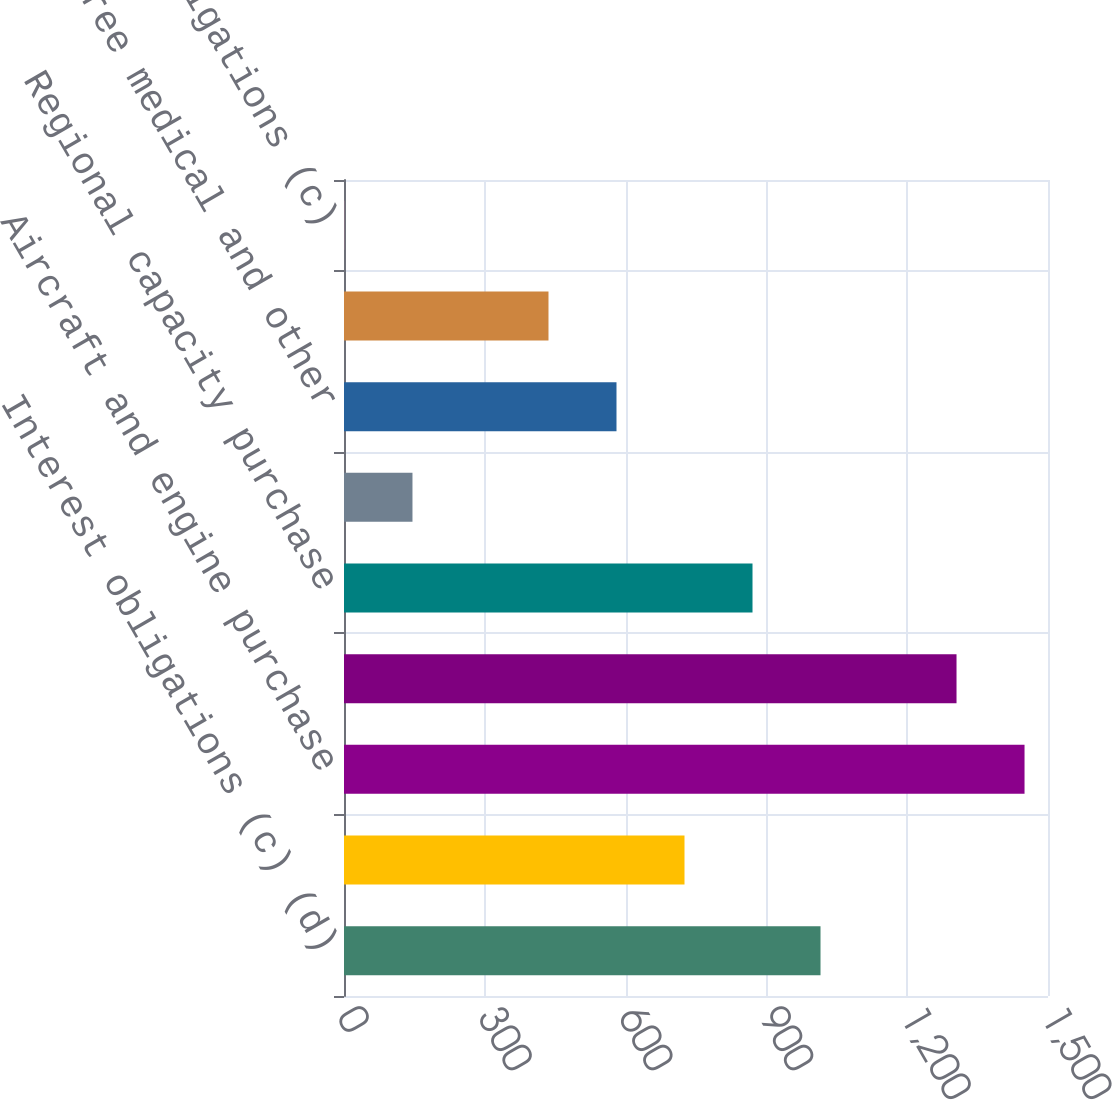Convert chart. <chart><loc_0><loc_0><loc_500><loc_500><bar_chart><fcel>Interest obligations (c) (d)<fcel>Finance lease obligations (See<fcel>Aircraft and engine purchase<fcel>Operating lease commitments<fcel>Regional capacity purchase<fcel>Minimum pension obligations<fcel>Retiree medical and other<fcel>Other purchase obligations (i)<fcel>Interest obligations (c)<nl><fcel>1015.3<fcel>725.5<fcel>1450<fcel>1305.1<fcel>870.4<fcel>145.9<fcel>580.6<fcel>435.7<fcel>1<nl></chart> 